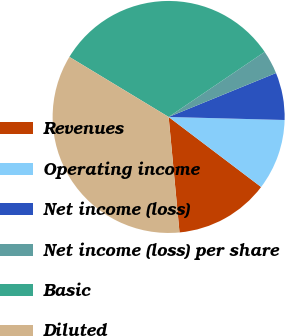Convert chart. <chart><loc_0><loc_0><loc_500><loc_500><pie_chart><fcel>Revenues<fcel>Operating income<fcel>Net income (loss)<fcel>Net income (loss) per share<fcel>Basic<fcel>Diluted<nl><fcel>13.19%<fcel>9.9%<fcel>6.6%<fcel>3.3%<fcel>31.86%<fcel>35.16%<nl></chart> 